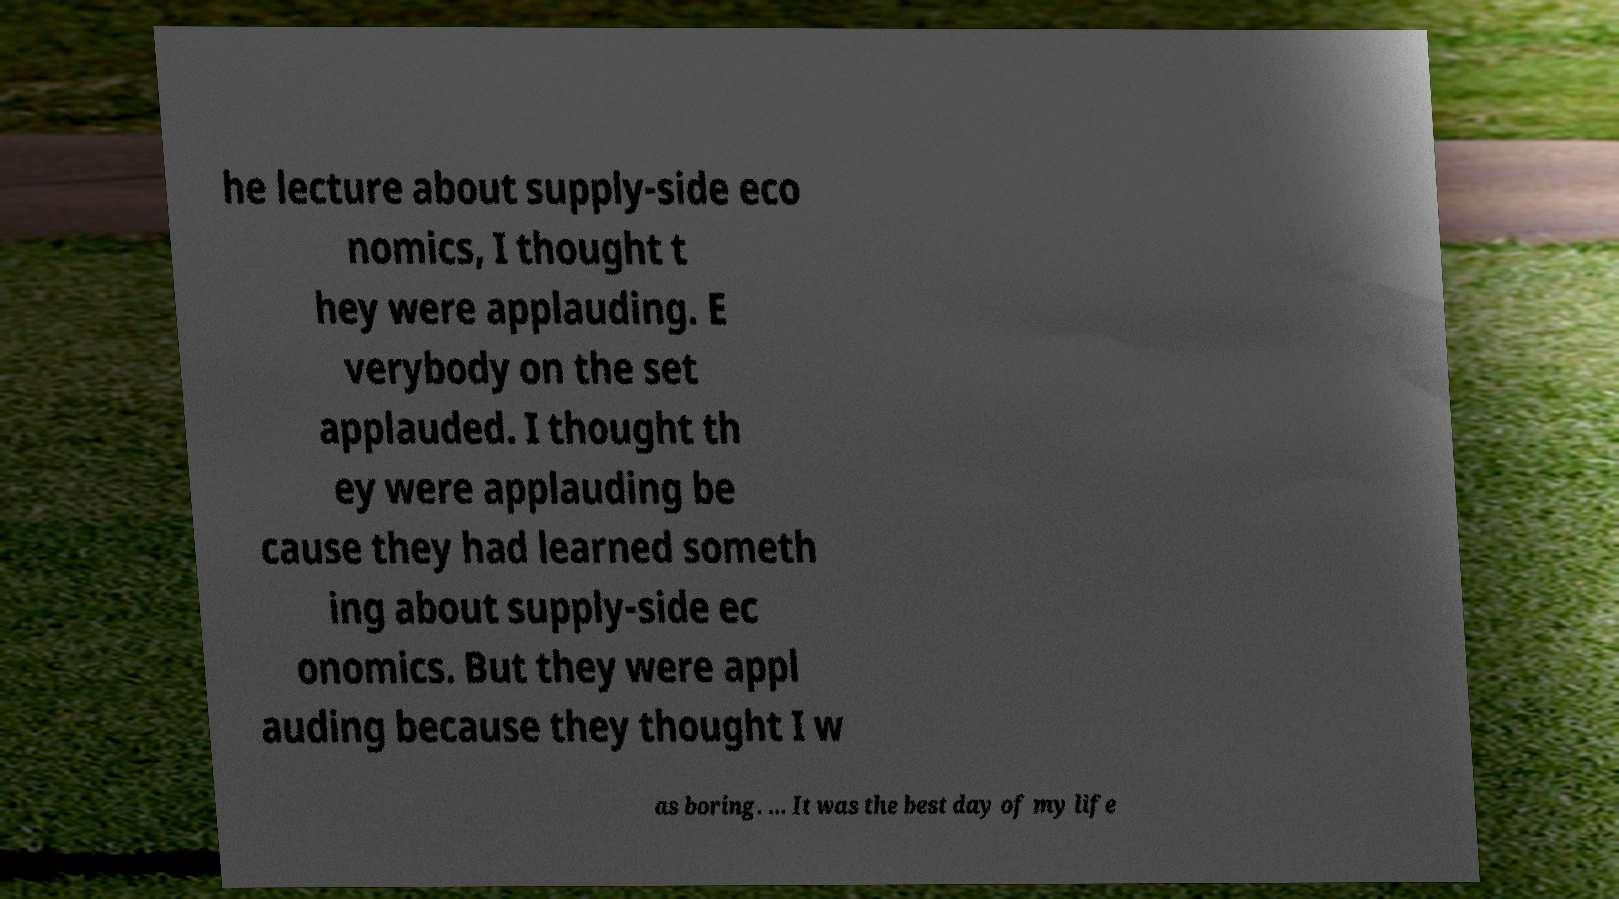Please identify and transcribe the text found in this image. he lecture about supply-side eco nomics, I thought t hey were applauding. E verybody on the set applauded. I thought th ey were applauding be cause they had learned someth ing about supply-side ec onomics. But they were appl auding because they thought I w as boring. ... It was the best day of my life 